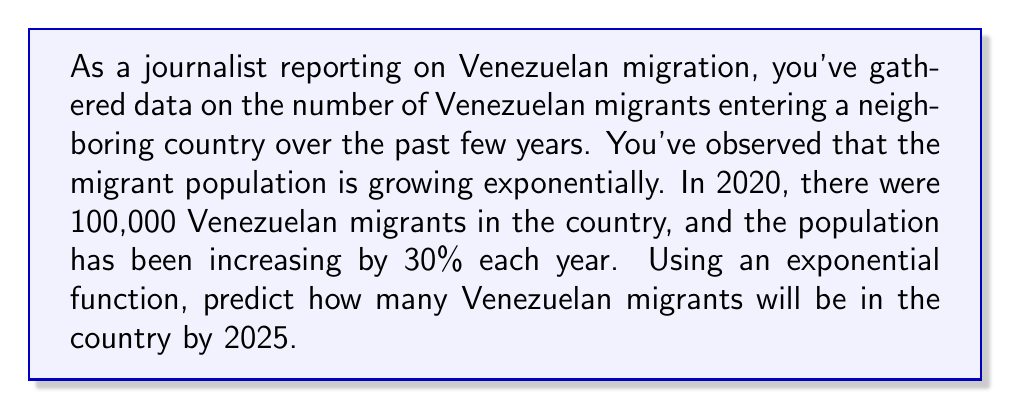Show me your answer to this math problem. To solve this problem, we need to use an exponential function in the form:

$$ P(t) = P_0 \cdot (1 + r)^t $$

Where:
$P(t)$ is the population after $t$ years
$P_0$ is the initial population
$r$ is the annual growth rate
$t$ is the number of years since the initial measurement

Given:
$P_0 = 100,000$ (initial population in 2020)
$r = 0.30$ (30% annual growth rate)
$t = 5$ (years from 2020 to 2025)

Let's substitute these values into our exponential function:

$$ P(5) = 100,000 \cdot (1 + 0.30)^5 $$

Now we can calculate:

$$ P(5) = 100,000 \cdot (1.30)^5 $$
$$ P(5) = 100,000 \cdot 3.71293 $$
$$ P(5) = 371,293 $$

Therefore, by 2025, there will be approximately 371,293 Venezuelan migrants in the country.
Answer: 371,293 Venezuelan migrants 